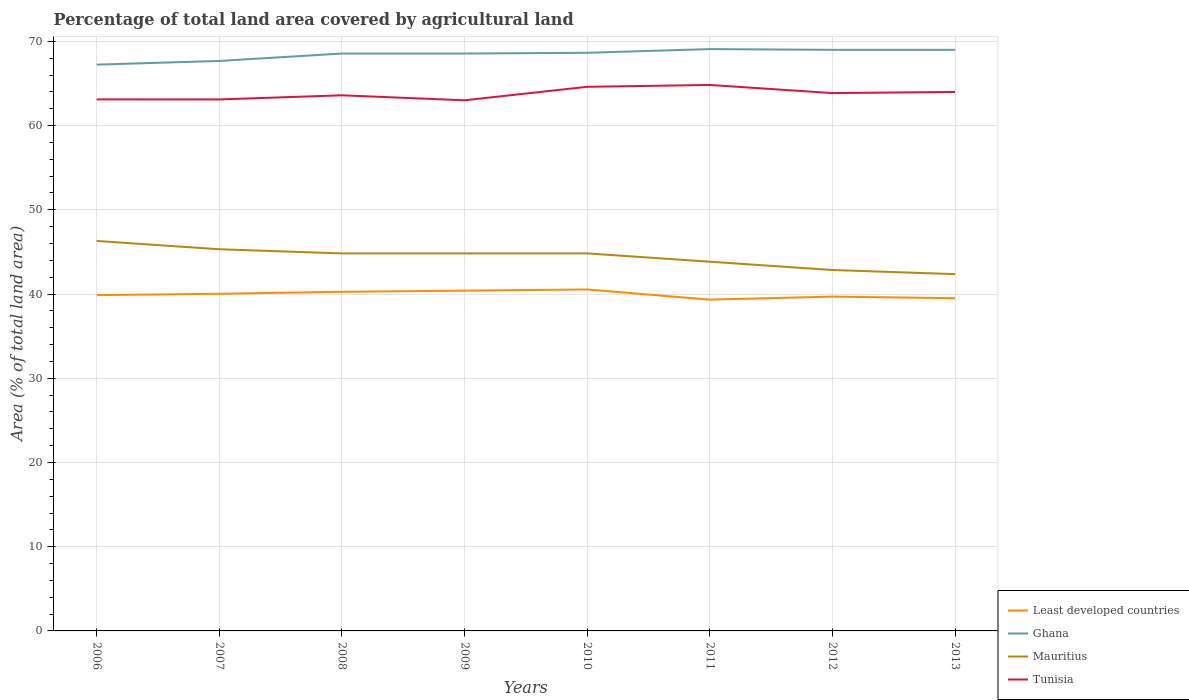Is the number of lines equal to the number of legend labels?
Your answer should be very brief. Yes. Across all years, what is the maximum percentage of agricultural land in Tunisia?
Your response must be concise. 63.01. What is the total percentage of agricultural land in Tunisia in the graph?
Your answer should be very brief. 0.75. What is the difference between the highest and the second highest percentage of agricultural land in Mauritius?
Offer a very short reply. 3.94. Is the percentage of agricultural land in Least developed countries strictly greater than the percentage of agricultural land in Tunisia over the years?
Provide a succinct answer. Yes. How many lines are there?
Provide a short and direct response. 4. What is the difference between two consecutive major ticks on the Y-axis?
Offer a terse response. 10. Does the graph contain grids?
Offer a terse response. Yes. What is the title of the graph?
Offer a very short reply. Percentage of total land area covered by agricultural land. Does "Burkina Faso" appear as one of the legend labels in the graph?
Offer a terse response. No. What is the label or title of the Y-axis?
Your answer should be compact. Area (% of total land area). What is the Area (% of total land area) of Least developed countries in 2006?
Provide a short and direct response. 39.87. What is the Area (% of total land area) of Ghana in 2006?
Provide a succinct answer. 67.24. What is the Area (% of total land area) in Mauritius in 2006?
Ensure brevity in your answer.  46.31. What is the Area (% of total land area) in Tunisia in 2006?
Offer a very short reply. 63.12. What is the Area (% of total land area) in Least developed countries in 2007?
Your answer should be very brief. 40.03. What is the Area (% of total land area) of Ghana in 2007?
Offer a very short reply. 67.68. What is the Area (% of total land area) of Mauritius in 2007?
Your response must be concise. 45.32. What is the Area (% of total land area) in Tunisia in 2007?
Your response must be concise. 63.11. What is the Area (% of total land area) in Least developed countries in 2008?
Give a very brief answer. 40.27. What is the Area (% of total land area) in Ghana in 2008?
Keep it short and to the point. 68.56. What is the Area (% of total land area) in Mauritius in 2008?
Your answer should be compact. 44.83. What is the Area (% of total land area) in Tunisia in 2008?
Your answer should be compact. 63.6. What is the Area (% of total land area) of Least developed countries in 2009?
Keep it short and to the point. 40.41. What is the Area (% of total land area) in Ghana in 2009?
Make the answer very short. 68.56. What is the Area (% of total land area) in Mauritius in 2009?
Keep it short and to the point. 44.83. What is the Area (% of total land area) in Tunisia in 2009?
Ensure brevity in your answer.  63.01. What is the Area (% of total land area) in Least developed countries in 2010?
Keep it short and to the point. 40.54. What is the Area (% of total land area) of Ghana in 2010?
Offer a terse response. 68.65. What is the Area (% of total land area) in Mauritius in 2010?
Keep it short and to the point. 44.83. What is the Area (% of total land area) in Tunisia in 2010?
Your answer should be compact. 64.61. What is the Area (% of total land area) of Least developed countries in 2011?
Your response must be concise. 39.34. What is the Area (% of total land area) in Ghana in 2011?
Give a very brief answer. 69.09. What is the Area (% of total land area) in Mauritius in 2011?
Keep it short and to the point. 43.84. What is the Area (% of total land area) of Tunisia in 2011?
Offer a terse response. 64.83. What is the Area (% of total land area) of Least developed countries in 2012?
Provide a succinct answer. 39.7. What is the Area (% of total land area) in Ghana in 2012?
Ensure brevity in your answer.  69. What is the Area (% of total land area) in Mauritius in 2012?
Offer a terse response. 42.86. What is the Area (% of total land area) in Tunisia in 2012?
Your answer should be compact. 63.86. What is the Area (% of total land area) of Least developed countries in 2013?
Provide a short and direct response. 39.51. What is the Area (% of total land area) of Ghana in 2013?
Provide a succinct answer. 69. What is the Area (% of total land area) of Mauritius in 2013?
Your answer should be compact. 42.36. What is the Area (% of total land area) in Tunisia in 2013?
Ensure brevity in your answer.  64. Across all years, what is the maximum Area (% of total land area) in Least developed countries?
Provide a succinct answer. 40.54. Across all years, what is the maximum Area (% of total land area) of Ghana?
Your answer should be very brief. 69.09. Across all years, what is the maximum Area (% of total land area) of Mauritius?
Provide a short and direct response. 46.31. Across all years, what is the maximum Area (% of total land area) in Tunisia?
Your response must be concise. 64.83. Across all years, what is the minimum Area (% of total land area) of Least developed countries?
Keep it short and to the point. 39.34. Across all years, what is the minimum Area (% of total land area) of Ghana?
Give a very brief answer. 67.24. Across all years, what is the minimum Area (% of total land area) of Mauritius?
Offer a very short reply. 42.36. Across all years, what is the minimum Area (% of total land area) of Tunisia?
Provide a short and direct response. 63.01. What is the total Area (% of total land area) in Least developed countries in the graph?
Give a very brief answer. 319.67. What is the total Area (% of total land area) of Ghana in the graph?
Your answer should be compact. 547.77. What is the total Area (% of total land area) in Mauritius in the graph?
Offer a terse response. 355.17. What is the total Area (% of total land area) in Tunisia in the graph?
Give a very brief answer. 510.14. What is the difference between the Area (% of total land area) in Least developed countries in 2006 and that in 2007?
Your response must be concise. -0.16. What is the difference between the Area (% of total land area) in Ghana in 2006 and that in 2007?
Ensure brevity in your answer.  -0.44. What is the difference between the Area (% of total land area) in Mauritius in 2006 and that in 2007?
Provide a succinct answer. 0.99. What is the difference between the Area (% of total land area) of Tunisia in 2006 and that in 2007?
Offer a very short reply. 0.01. What is the difference between the Area (% of total land area) in Least developed countries in 2006 and that in 2008?
Offer a very short reply. -0.4. What is the difference between the Area (% of total land area) in Ghana in 2006 and that in 2008?
Offer a terse response. -1.32. What is the difference between the Area (% of total land area) in Mauritius in 2006 and that in 2008?
Offer a terse response. 1.48. What is the difference between the Area (% of total land area) in Tunisia in 2006 and that in 2008?
Provide a succinct answer. -0.48. What is the difference between the Area (% of total land area) of Least developed countries in 2006 and that in 2009?
Your response must be concise. -0.54. What is the difference between the Area (% of total land area) of Ghana in 2006 and that in 2009?
Offer a very short reply. -1.32. What is the difference between the Area (% of total land area) of Mauritius in 2006 and that in 2009?
Keep it short and to the point. 1.48. What is the difference between the Area (% of total land area) in Tunisia in 2006 and that in 2009?
Provide a short and direct response. 0.11. What is the difference between the Area (% of total land area) of Least developed countries in 2006 and that in 2010?
Ensure brevity in your answer.  -0.67. What is the difference between the Area (% of total land area) of Ghana in 2006 and that in 2010?
Offer a very short reply. -1.41. What is the difference between the Area (% of total land area) in Mauritius in 2006 and that in 2010?
Offer a terse response. 1.48. What is the difference between the Area (% of total land area) in Tunisia in 2006 and that in 2010?
Offer a terse response. -1.49. What is the difference between the Area (% of total land area) in Least developed countries in 2006 and that in 2011?
Your response must be concise. 0.53. What is the difference between the Area (% of total land area) of Ghana in 2006 and that in 2011?
Provide a succinct answer. -1.85. What is the difference between the Area (% of total land area) in Mauritius in 2006 and that in 2011?
Ensure brevity in your answer.  2.46. What is the difference between the Area (% of total land area) of Tunisia in 2006 and that in 2011?
Give a very brief answer. -1.71. What is the difference between the Area (% of total land area) in Least developed countries in 2006 and that in 2012?
Make the answer very short. 0.17. What is the difference between the Area (% of total land area) in Ghana in 2006 and that in 2012?
Your response must be concise. -1.76. What is the difference between the Area (% of total land area) in Mauritius in 2006 and that in 2012?
Offer a very short reply. 3.45. What is the difference between the Area (% of total land area) in Tunisia in 2006 and that in 2012?
Your response must be concise. -0.75. What is the difference between the Area (% of total land area) of Least developed countries in 2006 and that in 2013?
Your response must be concise. 0.36. What is the difference between the Area (% of total land area) of Ghana in 2006 and that in 2013?
Keep it short and to the point. -1.76. What is the difference between the Area (% of total land area) in Mauritius in 2006 and that in 2013?
Your answer should be compact. 3.94. What is the difference between the Area (% of total land area) in Tunisia in 2006 and that in 2013?
Your response must be concise. -0.88. What is the difference between the Area (% of total land area) in Least developed countries in 2007 and that in 2008?
Ensure brevity in your answer.  -0.23. What is the difference between the Area (% of total land area) of Ghana in 2007 and that in 2008?
Make the answer very short. -0.88. What is the difference between the Area (% of total land area) in Mauritius in 2007 and that in 2008?
Offer a terse response. 0.49. What is the difference between the Area (% of total land area) of Tunisia in 2007 and that in 2008?
Your answer should be compact. -0.49. What is the difference between the Area (% of total land area) in Least developed countries in 2007 and that in 2009?
Your answer should be very brief. -0.37. What is the difference between the Area (% of total land area) in Ghana in 2007 and that in 2009?
Offer a very short reply. -0.88. What is the difference between the Area (% of total land area) of Mauritius in 2007 and that in 2009?
Provide a short and direct response. 0.49. What is the difference between the Area (% of total land area) in Tunisia in 2007 and that in 2009?
Provide a short and direct response. 0.1. What is the difference between the Area (% of total land area) of Least developed countries in 2007 and that in 2010?
Offer a terse response. -0.51. What is the difference between the Area (% of total land area) in Ghana in 2007 and that in 2010?
Keep it short and to the point. -0.97. What is the difference between the Area (% of total land area) in Mauritius in 2007 and that in 2010?
Ensure brevity in your answer.  0.49. What is the difference between the Area (% of total land area) in Tunisia in 2007 and that in 2010?
Your answer should be compact. -1.5. What is the difference between the Area (% of total land area) in Least developed countries in 2007 and that in 2011?
Make the answer very short. 0.69. What is the difference between the Area (% of total land area) in Ghana in 2007 and that in 2011?
Give a very brief answer. -1.41. What is the difference between the Area (% of total land area) in Mauritius in 2007 and that in 2011?
Provide a short and direct response. 1.48. What is the difference between the Area (% of total land area) of Tunisia in 2007 and that in 2011?
Keep it short and to the point. -1.72. What is the difference between the Area (% of total land area) of Least developed countries in 2007 and that in 2012?
Provide a succinct answer. 0.34. What is the difference between the Area (% of total land area) of Ghana in 2007 and that in 2012?
Your answer should be very brief. -1.32. What is the difference between the Area (% of total land area) in Mauritius in 2007 and that in 2012?
Offer a terse response. 2.46. What is the difference between the Area (% of total land area) in Tunisia in 2007 and that in 2012?
Ensure brevity in your answer.  -0.75. What is the difference between the Area (% of total land area) of Least developed countries in 2007 and that in 2013?
Your response must be concise. 0.52. What is the difference between the Area (% of total land area) in Ghana in 2007 and that in 2013?
Your answer should be compact. -1.32. What is the difference between the Area (% of total land area) in Mauritius in 2007 and that in 2013?
Provide a succinct answer. 2.96. What is the difference between the Area (% of total land area) in Tunisia in 2007 and that in 2013?
Keep it short and to the point. -0.89. What is the difference between the Area (% of total land area) in Least developed countries in 2008 and that in 2009?
Ensure brevity in your answer.  -0.14. What is the difference between the Area (% of total land area) in Ghana in 2008 and that in 2009?
Provide a succinct answer. 0. What is the difference between the Area (% of total land area) in Tunisia in 2008 and that in 2009?
Provide a short and direct response. 0.59. What is the difference between the Area (% of total land area) in Least developed countries in 2008 and that in 2010?
Your response must be concise. -0.28. What is the difference between the Area (% of total land area) of Ghana in 2008 and that in 2010?
Provide a succinct answer. -0.09. What is the difference between the Area (% of total land area) in Mauritius in 2008 and that in 2010?
Make the answer very short. 0. What is the difference between the Area (% of total land area) in Tunisia in 2008 and that in 2010?
Your answer should be very brief. -1.01. What is the difference between the Area (% of total land area) of Least developed countries in 2008 and that in 2011?
Your response must be concise. 0.93. What is the difference between the Area (% of total land area) of Ghana in 2008 and that in 2011?
Make the answer very short. -0.53. What is the difference between the Area (% of total land area) of Mauritius in 2008 and that in 2011?
Give a very brief answer. 0.99. What is the difference between the Area (% of total land area) of Tunisia in 2008 and that in 2011?
Give a very brief answer. -1.23. What is the difference between the Area (% of total land area) of Least developed countries in 2008 and that in 2012?
Give a very brief answer. 0.57. What is the difference between the Area (% of total land area) in Ghana in 2008 and that in 2012?
Give a very brief answer. -0.44. What is the difference between the Area (% of total land area) in Mauritius in 2008 and that in 2012?
Provide a short and direct response. 1.97. What is the difference between the Area (% of total land area) in Tunisia in 2008 and that in 2012?
Offer a very short reply. -0.26. What is the difference between the Area (% of total land area) in Least developed countries in 2008 and that in 2013?
Keep it short and to the point. 0.76. What is the difference between the Area (% of total land area) in Ghana in 2008 and that in 2013?
Give a very brief answer. -0.44. What is the difference between the Area (% of total land area) of Mauritius in 2008 and that in 2013?
Provide a succinct answer. 2.46. What is the difference between the Area (% of total land area) in Tunisia in 2008 and that in 2013?
Offer a terse response. -0.4. What is the difference between the Area (% of total land area) in Least developed countries in 2009 and that in 2010?
Provide a succinct answer. -0.14. What is the difference between the Area (% of total land area) of Ghana in 2009 and that in 2010?
Keep it short and to the point. -0.09. What is the difference between the Area (% of total land area) in Mauritius in 2009 and that in 2010?
Make the answer very short. 0. What is the difference between the Area (% of total land area) of Tunisia in 2009 and that in 2010?
Provide a succinct answer. -1.6. What is the difference between the Area (% of total land area) of Least developed countries in 2009 and that in 2011?
Provide a short and direct response. 1.07. What is the difference between the Area (% of total land area) in Ghana in 2009 and that in 2011?
Give a very brief answer. -0.53. What is the difference between the Area (% of total land area) in Mauritius in 2009 and that in 2011?
Ensure brevity in your answer.  0.99. What is the difference between the Area (% of total land area) in Tunisia in 2009 and that in 2011?
Offer a terse response. -1.82. What is the difference between the Area (% of total land area) in Least developed countries in 2009 and that in 2012?
Make the answer very short. 0.71. What is the difference between the Area (% of total land area) in Ghana in 2009 and that in 2012?
Your answer should be very brief. -0.44. What is the difference between the Area (% of total land area) in Mauritius in 2009 and that in 2012?
Keep it short and to the point. 1.97. What is the difference between the Area (% of total land area) in Tunisia in 2009 and that in 2012?
Keep it short and to the point. -0.86. What is the difference between the Area (% of total land area) of Least developed countries in 2009 and that in 2013?
Offer a terse response. 0.9. What is the difference between the Area (% of total land area) of Ghana in 2009 and that in 2013?
Keep it short and to the point. -0.44. What is the difference between the Area (% of total land area) of Mauritius in 2009 and that in 2013?
Your answer should be very brief. 2.46. What is the difference between the Area (% of total land area) of Tunisia in 2009 and that in 2013?
Offer a terse response. -0.99. What is the difference between the Area (% of total land area) in Least developed countries in 2010 and that in 2011?
Offer a terse response. 1.21. What is the difference between the Area (% of total land area) of Ghana in 2010 and that in 2011?
Offer a very short reply. -0.44. What is the difference between the Area (% of total land area) in Mauritius in 2010 and that in 2011?
Provide a succinct answer. 0.99. What is the difference between the Area (% of total land area) in Tunisia in 2010 and that in 2011?
Keep it short and to the point. -0.22. What is the difference between the Area (% of total land area) in Least developed countries in 2010 and that in 2012?
Give a very brief answer. 0.85. What is the difference between the Area (% of total land area) of Ghana in 2010 and that in 2012?
Make the answer very short. -0.35. What is the difference between the Area (% of total land area) in Mauritius in 2010 and that in 2012?
Ensure brevity in your answer.  1.97. What is the difference between the Area (% of total land area) of Tunisia in 2010 and that in 2012?
Keep it short and to the point. 0.75. What is the difference between the Area (% of total land area) of Least developed countries in 2010 and that in 2013?
Your answer should be compact. 1.03. What is the difference between the Area (% of total land area) of Ghana in 2010 and that in 2013?
Provide a short and direct response. -0.35. What is the difference between the Area (% of total land area) in Mauritius in 2010 and that in 2013?
Your answer should be compact. 2.46. What is the difference between the Area (% of total land area) of Tunisia in 2010 and that in 2013?
Make the answer very short. 0.61. What is the difference between the Area (% of total land area) in Least developed countries in 2011 and that in 2012?
Your answer should be very brief. -0.36. What is the difference between the Area (% of total land area) of Ghana in 2011 and that in 2012?
Your response must be concise. 0.09. What is the difference between the Area (% of total land area) of Mauritius in 2011 and that in 2012?
Your response must be concise. 0.99. What is the difference between the Area (% of total land area) in Tunisia in 2011 and that in 2012?
Your answer should be compact. 0.97. What is the difference between the Area (% of total land area) of Least developed countries in 2011 and that in 2013?
Give a very brief answer. -0.17. What is the difference between the Area (% of total land area) in Ghana in 2011 and that in 2013?
Provide a short and direct response. 0.09. What is the difference between the Area (% of total land area) in Mauritius in 2011 and that in 2013?
Your response must be concise. 1.48. What is the difference between the Area (% of total land area) of Tunisia in 2011 and that in 2013?
Provide a succinct answer. 0.83. What is the difference between the Area (% of total land area) in Least developed countries in 2012 and that in 2013?
Provide a short and direct response. 0.19. What is the difference between the Area (% of total land area) in Ghana in 2012 and that in 2013?
Keep it short and to the point. 0. What is the difference between the Area (% of total land area) in Mauritius in 2012 and that in 2013?
Give a very brief answer. 0.49. What is the difference between the Area (% of total land area) in Tunisia in 2012 and that in 2013?
Give a very brief answer. -0.14. What is the difference between the Area (% of total land area) of Least developed countries in 2006 and the Area (% of total land area) of Ghana in 2007?
Your response must be concise. -27.81. What is the difference between the Area (% of total land area) of Least developed countries in 2006 and the Area (% of total land area) of Mauritius in 2007?
Your answer should be compact. -5.45. What is the difference between the Area (% of total land area) of Least developed countries in 2006 and the Area (% of total land area) of Tunisia in 2007?
Give a very brief answer. -23.24. What is the difference between the Area (% of total land area) in Ghana in 2006 and the Area (% of total land area) in Mauritius in 2007?
Ensure brevity in your answer.  21.92. What is the difference between the Area (% of total land area) of Ghana in 2006 and the Area (% of total land area) of Tunisia in 2007?
Your answer should be very brief. 4.13. What is the difference between the Area (% of total land area) of Mauritius in 2006 and the Area (% of total land area) of Tunisia in 2007?
Your response must be concise. -16.81. What is the difference between the Area (% of total land area) of Least developed countries in 2006 and the Area (% of total land area) of Ghana in 2008?
Keep it short and to the point. -28.69. What is the difference between the Area (% of total land area) in Least developed countries in 2006 and the Area (% of total land area) in Mauritius in 2008?
Offer a very short reply. -4.96. What is the difference between the Area (% of total land area) in Least developed countries in 2006 and the Area (% of total land area) in Tunisia in 2008?
Ensure brevity in your answer.  -23.73. What is the difference between the Area (% of total land area) of Ghana in 2006 and the Area (% of total land area) of Mauritius in 2008?
Your answer should be compact. 22.41. What is the difference between the Area (% of total land area) in Ghana in 2006 and the Area (% of total land area) in Tunisia in 2008?
Ensure brevity in your answer.  3.64. What is the difference between the Area (% of total land area) of Mauritius in 2006 and the Area (% of total land area) of Tunisia in 2008?
Your answer should be compact. -17.3. What is the difference between the Area (% of total land area) of Least developed countries in 2006 and the Area (% of total land area) of Ghana in 2009?
Offer a terse response. -28.69. What is the difference between the Area (% of total land area) in Least developed countries in 2006 and the Area (% of total land area) in Mauritius in 2009?
Ensure brevity in your answer.  -4.96. What is the difference between the Area (% of total land area) in Least developed countries in 2006 and the Area (% of total land area) in Tunisia in 2009?
Your answer should be very brief. -23.14. What is the difference between the Area (% of total land area) in Ghana in 2006 and the Area (% of total land area) in Mauritius in 2009?
Offer a very short reply. 22.41. What is the difference between the Area (% of total land area) of Ghana in 2006 and the Area (% of total land area) of Tunisia in 2009?
Ensure brevity in your answer.  4.23. What is the difference between the Area (% of total land area) of Mauritius in 2006 and the Area (% of total land area) of Tunisia in 2009?
Offer a very short reply. -16.7. What is the difference between the Area (% of total land area) of Least developed countries in 2006 and the Area (% of total land area) of Ghana in 2010?
Keep it short and to the point. -28.78. What is the difference between the Area (% of total land area) in Least developed countries in 2006 and the Area (% of total land area) in Mauritius in 2010?
Your answer should be very brief. -4.96. What is the difference between the Area (% of total land area) of Least developed countries in 2006 and the Area (% of total land area) of Tunisia in 2010?
Provide a succinct answer. -24.74. What is the difference between the Area (% of total land area) of Ghana in 2006 and the Area (% of total land area) of Mauritius in 2010?
Offer a terse response. 22.41. What is the difference between the Area (% of total land area) in Ghana in 2006 and the Area (% of total land area) in Tunisia in 2010?
Give a very brief answer. 2.63. What is the difference between the Area (% of total land area) in Mauritius in 2006 and the Area (% of total land area) in Tunisia in 2010?
Ensure brevity in your answer.  -18.31. What is the difference between the Area (% of total land area) in Least developed countries in 2006 and the Area (% of total land area) in Ghana in 2011?
Give a very brief answer. -29.22. What is the difference between the Area (% of total land area) in Least developed countries in 2006 and the Area (% of total land area) in Mauritius in 2011?
Provide a succinct answer. -3.97. What is the difference between the Area (% of total land area) in Least developed countries in 2006 and the Area (% of total land area) in Tunisia in 2011?
Provide a succinct answer. -24.96. What is the difference between the Area (% of total land area) of Ghana in 2006 and the Area (% of total land area) of Mauritius in 2011?
Your response must be concise. 23.4. What is the difference between the Area (% of total land area) in Ghana in 2006 and the Area (% of total land area) in Tunisia in 2011?
Your answer should be compact. 2.41. What is the difference between the Area (% of total land area) of Mauritius in 2006 and the Area (% of total land area) of Tunisia in 2011?
Keep it short and to the point. -18.52. What is the difference between the Area (% of total land area) of Least developed countries in 2006 and the Area (% of total land area) of Ghana in 2012?
Offer a very short reply. -29.13. What is the difference between the Area (% of total land area) of Least developed countries in 2006 and the Area (% of total land area) of Mauritius in 2012?
Make the answer very short. -2.99. What is the difference between the Area (% of total land area) of Least developed countries in 2006 and the Area (% of total land area) of Tunisia in 2012?
Your response must be concise. -23.99. What is the difference between the Area (% of total land area) of Ghana in 2006 and the Area (% of total land area) of Mauritius in 2012?
Your answer should be compact. 24.38. What is the difference between the Area (% of total land area) in Ghana in 2006 and the Area (% of total land area) in Tunisia in 2012?
Keep it short and to the point. 3.38. What is the difference between the Area (% of total land area) in Mauritius in 2006 and the Area (% of total land area) in Tunisia in 2012?
Make the answer very short. -17.56. What is the difference between the Area (% of total land area) of Least developed countries in 2006 and the Area (% of total land area) of Ghana in 2013?
Provide a succinct answer. -29.13. What is the difference between the Area (% of total land area) in Least developed countries in 2006 and the Area (% of total land area) in Mauritius in 2013?
Provide a short and direct response. -2.49. What is the difference between the Area (% of total land area) of Least developed countries in 2006 and the Area (% of total land area) of Tunisia in 2013?
Provide a succinct answer. -24.13. What is the difference between the Area (% of total land area) of Ghana in 2006 and the Area (% of total land area) of Mauritius in 2013?
Your response must be concise. 24.88. What is the difference between the Area (% of total land area) in Ghana in 2006 and the Area (% of total land area) in Tunisia in 2013?
Provide a short and direct response. 3.24. What is the difference between the Area (% of total land area) of Mauritius in 2006 and the Area (% of total land area) of Tunisia in 2013?
Ensure brevity in your answer.  -17.69. What is the difference between the Area (% of total land area) of Least developed countries in 2007 and the Area (% of total land area) of Ghana in 2008?
Make the answer very short. -28.53. What is the difference between the Area (% of total land area) of Least developed countries in 2007 and the Area (% of total land area) of Mauritius in 2008?
Your response must be concise. -4.79. What is the difference between the Area (% of total land area) of Least developed countries in 2007 and the Area (% of total land area) of Tunisia in 2008?
Provide a short and direct response. -23.57. What is the difference between the Area (% of total land area) of Ghana in 2007 and the Area (% of total land area) of Mauritius in 2008?
Ensure brevity in your answer.  22.85. What is the difference between the Area (% of total land area) in Ghana in 2007 and the Area (% of total land area) in Tunisia in 2008?
Provide a short and direct response. 4.08. What is the difference between the Area (% of total land area) in Mauritius in 2007 and the Area (% of total land area) in Tunisia in 2008?
Ensure brevity in your answer.  -18.28. What is the difference between the Area (% of total land area) in Least developed countries in 2007 and the Area (% of total land area) in Ghana in 2009?
Provide a succinct answer. -28.53. What is the difference between the Area (% of total land area) in Least developed countries in 2007 and the Area (% of total land area) in Mauritius in 2009?
Give a very brief answer. -4.79. What is the difference between the Area (% of total land area) in Least developed countries in 2007 and the Area (% of total land area) in Tunisia in 2009?
Your answer should be very brief. -22.97. What is the difference between the Area (% of total land area) of Ghana in 2007 and the Area (% of total land area) of Mauritius in 2009?
Your answer should be very brief. 22.85. What is the difference between the Area (% of total land area) of Ghana in 2007 and the Area (% of total land area) of Tunisia in 2009?
Give a very brief answer. 4.67. What is the difference between the Area (% of total land area) of Mauritius in 2007 and the Area (% of total land area) of Tunisia in 2009?
Make the answer very short. -17.69. What is the difference between the Area (% of total land area) of Least developed countries in 2007 and the Area (% of total land area) of Ghana in 2010?
Provide a succinct answer. -28.61. What is the difference between the Area (% of total land area) of Least developed countries in 2007 and the Area (% of total land area) of Mauritius in 2010?
Make the answer very short. -4.79. What is the difference between the Area (% of total land area) of Least developed countries in 2007 and the Area (% of total land area) of Tunisia in 2010?
Offer a terse response. -24.58. What is the difference between the Area (% of total land area) of Ghana in 2007 and the Area (% of total land area) of Mauritius in 2010?
Ensure brevity in your answer.  22.85. What is the difference between the Area (% of total land area) in Ghana in 2007 and the Area (% of total land area) in Tunisia in 2010?
Provide a short and direct response. 3.07. What is the difference between the Area (% of total land area) in Mauritius in 2007 and the Area (% of total land area) in Tunisia in 2010?
Your response must be concise. -19.29. What is the difference between the Area (% of total land area) of Least developed countries in 2007 and the Area (% of total land area) of Ghana in 2011?
Offer a very short reply. -29.05. What is the difference between the Area (% of total land area) in Least developed countries in 2007 and the Area (% of total land area) in Mauritius in 2011?
Offer a very short reply. -3.81. What is the difference between the Area (% of total land area) of Least developed countries in 2007 and the Area (% of total land area) of Tunisia in 2011?
Offer a terse response. -24.8. What is the difference between the Area (% of total land area) of Ghana in 2007 and the Area (% of total land area) of Mauritius in 2011?
Provide a short and direct response. 23.84. What is the difference between the Area (% of total land area) in Ghana in 2007 and the Area (% of total land area) in Tunisia in 2011?
Give a very brief answer. 2.85. What is the difference between the Area (% of total land area) in Mauritius in 2007 and the Area (% of total land area) in Tunisia in 2011?
Keep it short and to the point. -19.51. What is the difference between the Area (% of total land area) in Least developed countries in 2007 and the Area (% of total land area) in Ghana in 2012?
Your answer should be compact. -28.97. What is the difference between the Area (% of total land area) of Least developed countries in 2007 and the Area (% of total land area) of Mauritius in 2012?
Your answer should be compact. -2.82. What is the difference between the Area (% of total land area) in Least developed countries in 2007 and the Area (% of total land area) in Tunisia in 2012?
Your response must be concise. -23.83. What is the difference between the Area (% of total land area) in Ghana in 2007 and the Area (% of total land area) in Mauritius in 2012?
Ensure brevity in your answer.  24.82. What is the difference between the Area (% of total land area) of Ghana in 2007 and the Area (% of total land area) of Tunisia in 2012?
Your answer should be very brief. 3.82. What is the difference between the Area (% of total land area) in Mauritius in 2007 and the Area (% of total land area) in Tunisia in 2012?
Provide a short and direct response. -18.54. What is the difference between the Area (% of total land area) of Least developed countries in 2007 and the Area (% of total land area) of Ghana in 2013?
Your answer should be compact. -28.97. What is the difference between the Area (% of total land area) in Least developed countries in 2007 and the Area (% of total land area) in Mauritius in 2013?
Your answer should be very brief. -2.33. What is the difference between the Area (% of total land area) of Least developed countries in 2007 and the Area (% of total land area) of Tunisia in 2013?
Your answer should be compact. -23.97. What is the difference between the Area (% of total land area) of Ghana in 2007 and the Area (% of total land area) of Mauritius in 2013?
Your answer should be very brief. 25.32. What is the difference between the Area (% of total land area) of Ghana in 2007 and the Area (% of total land area) of Tunisia in 2013?
Your response must be concise. 3.68. What is the difference between the Area (% of total land area) in Mauritius in 2007 and the Area (% of total land area) in Tunisia in 2013?
Make the answer very short. -18.68. What is the difference between the Area (% of total land area) of Least developed countries in 2008 and the Area (% of total land area) of Ghana in 2009?
Your answer should be compact. -28.29. What is the difference between the Area (% of total land area) of Least developed countries in 2008 and the Area (% of total land area) of Mauritius in 2009?
Your answer should be very brief. -4.56. What is the difference between the Area (% of total land area) of Least developed countries in 2008 and the Area (% of total land area) of Tunisia in 2009?
Your answer should be very brief. -22.74. What is the difference between the Area (% of total land area) of Ghana in 2008 and the Area (% of total land area) of Mauritius in 2009?
Offer a terse response. 23.73. What is the difference between the Area (% of total land area) in Ghana in 2008 and the Area (% of total land area) in Tunisia in 2009?
Make the answer very short. 5.55. What is the difference between the Area (% of total land area) in Mauritius in 2008 and the Area (% of total land area) in Tunisia in 2009?
Keep it short and to the point. -18.18. What is the difference between the Area (% of total land area) in Least developed countries in 2008 and the Area (% of total land area) in Ghana in 2010?
Your answer should be compact. -28.38. What is the difference between the Area (% of total land area) of Least developed countries in 2008 and the Area (% of total land area) of Mauritius in 2010?
Your answer should be very brief. -4.56. What is the difference between the Area (% of total land area) of Least developed countries in 2008 and the Area (% of total land area) of Tunisia in 2010?
Make the answer very short. -24.34. What is the difference between the Area (% of total land area) in Ghana in 2008 and the Area (% of total land area) in Mauritius in 2010?
Provide a short and direct response. 23.73. What is the difference between the Area (% of total land area) of Ghana in 2008 and the Area (% of total land area) of Tunisia in 2010?
Ensure brevity in your answer.  3.95. What is the difference between the Area (% of total land area) of Mauritius in 2008 and the Area (% of total land area) of Tunisia in 2010?
Provide a short and direct response. -19.78. What is the difference between the Area (% of total land area) of Least developed countries in 2008 and the Area (% of total land area) of Ghana in 2011?
Ensure brevity in your answer.  -28.82. What is the difference between the Area (% of total land area) of Least developed countries in 2008 and the Area (% of total land area) of Mauritius in 2011?
Your answer should be very brief. -3.58. What is the difference between the Area (% of total land area) of Least developed countries in 2008 and the Area (% of total land area) of Tunisia in 2011?
Offer a terse response. -24.56. What is the difference between the Area (% of total land area) of Ghana in 2008 and the Area (% of total land area) of Mauritius in 2011?
Give a very brief answer. 24.72. What is the difference between the Area (% of total land area) in Ghana in 2008 and the Area (% of total land area) in Tunisia in 2011?
Ensure brevity in your answer.  3.73. What is the difference between the Area (% of total land area) in Mauritius in 2008 and the Area (% of total land area) in Tunisia in 2011?
Ensure brevity in your answer.  -20. What is the difference between the Area (% of total land area) in Least developed countries in 2008 and the Area (% of total land area) in Ghana in 2012?
Keep it short and to the point. -28.73. What is the difference between the Area (% of total land area) of Least developed countries in 2008 and the Area (% of total land area) of Mauritius in 2012?
Offer a terse response. -2.59. What is the difference between the Area (% of total land area) in Least developed countries in 2008 and the Area (% of total land area) in Tunisia in 2012?
Provide a short and direct response. -23.6. What is the difference between the Area (% of total land area) in Ghana in 2008 and the Area (% of total land area) in Mauritius in 2012?
Your answer should be very brief. 25.7. What is the difference between the Area (% of total land area) in Ghana in 2008 and the Area (% of total land area) in Tunisia in 2012?
Keep it short and to the point. 4.69. What is the difference between the Area (% of total land area) in Mauritius in 2008 and the Area (% of total land area) in Tunisia in 2012?
Give a very brief answer. -19.04. What is the difference between the Area (% of total land area) of Least developed countries in 2008 and the Area (% of total land area) of Ghana in 2013?
Your answer should be very brief. -28.73. What is the difference between the Area (% of total land area) of Least developed countries in 2008 and the Area (% of total land area) of Mauritius in 2013?
Your response must be concise. -2.1. What is the difference between the Area (% of total land area) in Least developed countries in 2008 and the Area (% of total land area) in Tunisia in 2013?
Offer a terse response. -23.73. What is the difference between the Area (% of total land area) in Ghana in 2008 and the Area (% of total land area) in Mauritius in 2013?
Provide a short and direct response. 26.19. What is the difference between the Area (% of total land area) in Ghana in 2008 and the Area (% of total land area) in Tunisia in 2013?
Your response must be concise. 4.56. What is the difference between the Area (% of total land area) of Mauritius in 2008 and the Area (% of total land area) of Tunisia in 2013?
Provide a succinct answer. -19.17. What is the difference between the Area (% of total land area) of Least developed countries in 2009 and the Area (% of total land area) of Ghana in 2010?
Give a very brief answer. -28.24. What is the difference between the Area (% of total land area) in Least developed countries in 2009 and the Area (% of total land area) in Mauritius in 2010?
Give a very brief answer. -4.42. What is the difference between the Area (% of total land area) of Least developed countries in 2009 and the Area (% of total land area) of Tunisia in 2010?
Give a very brief answer. -24.2. What is the difference between the Area (% of total land area) in Ghana in 2009 and the Area (% of total land area) in Mauritius in 2010?
Your answer should be compact. 23.73. What is the difference between the Area (% of total land area) in Ghana in 2009 and the Area (% of total land area) in Tunisia in 2010?
Make the answer very short. 3.95. What is the difference between the Area (% of total land area) in Mauritius in 2009 and the Area (% of total land area) in Tunisia in 2010?
Keep it short and to the point. -19.78. What is the difference between the Area (% of total land area) of Least developed countries in 2009 and the Area (% of total land area) of Ghana in 2011?
Provide a short and direct response. -28.68. What is the difference between the Area (% of total land area) in Least developed countries in 2009 and the Area (% of total land area) in Mauritius in 2011?
Provide a succinct answer. -3.43. What is the difference between the Area (% of total land area) in Least developed countries in 2009 and the Area (% of total land area) in Tunisia in 2011?
Provide a succinct answer. -24.42. What is the difference between the Area (% of total land area) of Ghana in 2009 and the Area (% of total land area) of Mauritius in 2011?
Your response must be concise. 24.72. What is the difference between the Area (% of total land area) in Ghana in 2009 and the Area (% of total land area) in Tunisia in 2011?
Your answer should be compact. 3.73. What is the difference between the Area (% of total land area) in Mauritius in 2009 and the Area (% of total land area) in Tunisia in 2011?
Ensure brevity in your answer.  -20. What is the difference between the Area (% of total land area) in Least developed countries in 2009 and the Area (% of total land area) in Ghana in 2012?
Ensure brevity in your answer.  -28.59. What is the difference between the Area (% of total land area) of Least developed countries in 2009 and the Area (% of total land area) of Mauritius in 2012?
Keep it short and to the point. -2.45. What is the difference between the Area (% of total land area) of Least developed countries in 2009 and the Area (% of total land area) of Tunisia in 2012?
Make the answer very short. -23.46. What is the difference between the Area (% of total land area) in Ghana in 2009 and the Area (% of total land area) in Mauritius in 2012?
Offer a terse response. 25.7. What is the difference between the Area (% of total land area) of Ghana in 2009 and the Area (% of total land area) of Tunisia in 2012?
Give a very brief answer. 4.69. What is the difference between the Area (% of total land area) of Mauritius in 2009 and the Area (% of total land area) of Tunisia in 2012?
Your response must be concise. -19.04. What is the difference between the Area (% of total land area) of Least developed countries in 2009 and the Area (% of total land area) of Ghana in 2013?
Your answer should be very brief. -28.59. What is the difference between the Area (% of total land area) of Least developed countries in 2009 and the Area (% of total land area) of Mauritius in 2013?
Your answer should be very brief. -1.96. What is the difference between the Area (% of total land area) of Least developed countries in 2009 and the Area (% of total land area) of Tunisia in 2013?
Your answer should be very brief. -23.59. What is the difference between the Area (% of total land area) of Ghana in 2009 and the Area (% of total land area) of Mauritius in 2013?
Your answer should be very brief. 26.19. What is the difference between the Area (% of total land area) in Ghana in 2009 and the Area (% of total land area) in Tunisia in 2013?
Give a very brief answer. 4.56. What is the difference between the Area (% of total land area) in Mauritius in 2009 and the Area (% of total land area) in Tunisia in 2013?
Offer a terse response. -19.17. What is the difference between the Area (% of total land area) in Least developed countries in 2010 and the Area (% of total land area) in Ghana in 2011?
Provide a short and direct response. -28.54. What is the difference between the Area (% of total land area) of Least developed countries in 2010 and the Area (% of total land area) of Mauritius in 2011?
Keep it short and to the point. -3.3. What is the difference between the Area (% of total land area) in Least developed countries in 2010 and the Area (% of total land area) in Tunisia in 2011?
Provide a succinct answer. -24.29. What is the difference between the Area (% of total land area) of Ghana in 2010 and the Area (% of total land area) of Mauritius in 2011?
Your answer should be very brief. 24.8. What is the difference between the Area (% of total land area) of Ghana in 2010 and the Area (% of total land area) of Tunisia in 2011?
Provide a short and direct response. 3.82. What is the difference between the Area (% of total land area) in Mauritius in 2010 and the Area (% of total land area) in Tunisia in 2011?
Your response must be concise. -20. What is the difference between the Area (% of total land area) in Least developed countries in 2010 and the Area (% of total land area) in Ghana in 2012?
Ensure brevity in your answer.  -28.45. What is the difference between the Area (% of total land area) of Least developed countries in 2010 and the Area (% of total land area) of Mauritius in 2012?
Your answer should be very brief. -2.31. What is the difference between the Area (% of total land area) of Least developed countries in 2010 and the Area (% of total land area) of Tunisia in 2012?
Your answer should be very brief. -23.32. What is the difference between the Area (% of total land area) of Ghana in 2010 and the Area (% of total land area) of Mauritius in 2012?
Ensure brevity in your answer.  25.79. What is the difference between the Area (% of total land area) of Ghana in 2010 and the Area (% of total land area) of Tunisia in 2012?
Offer a very short reply. 4.78. What is the difference between the Area (% of total land area) in Mauritius in 2010 and the Area (% of total land area) in Tunisia in 2012?
Provide a succinct answer. -19.04. What is the difference between the Area (% of total land area) in Least developed countries in 2010 and the Area (% of total land area) in Ghana in 2013?
Make the answer very short. -28.45. What is the difference between the Area (% of total land area) in Least developed countries in 2010 and the Area (% of total land area) in Mauritius in 2013?
Provide a succinct answer. -1.82. What is the difference between the Area (% of total land area) of Least developed countries in 2010 and the Area (% of total land area) of Tunisia in 2013?
Ensure brevity in your answer.  -23.45. What is the difference between the Area (% of total land area) in Ghana in 2010 and the Area (% of total land area) in Mauritius in 2013?
Provide a short and direct response. 26.28. What is the difference between the Area (% of total land area) in Ghana in 2010 and the Area (% of total land area) in Tunisia in 2013?
Make the answer very short. 4.65. What is the difference between the Area (% of total land area) in Mauritius in 2010 and the Area (% of total land area) in Tunisia in 2013?
Make the answer very short. -19.17. What is the difference between the Area (% of total land area) in Least developed countries in 2011 and the Area (% of total land area) in Ghana in 2012?
Offer a terse response. -29.66. What is the difference between the Area (% of total land area) in Least developed countries in 2011 and the Area (% of total land area) in Mauritius in 2012?
Your answer should be very brief. -3.52. What is the difference between the Area (% of total land area) of Least developed countries in 2011 and the Area (% of total land area) of Tunisia in 2012?
Your answer should be compact. -24.53. What is the difference between the Area (% of total land area) of Ghana in 2011 and the Area (% of total land area) of Mauritius in 2012?
Give a very brief answer. 26.23. What is the difference between the Area (% of total land area) of Ghana in 2011 and the Area (% of total land area) of Tunisia in 2012?
Your answer should be very brief. 5.22. What is the difference between the Area (% of total land area) of Mauritius in 2011 and the Area (% of total land area) of Tunisia in 2012?
Ensure brevity in your answer.  -20.02. What is the difference between the Area (% of total land area) of Least developed countries in 2011 and the Area (% of total land area) of Ghana in 2013?
Your answer should be very brief. -29.66. What is the difference between the Area (% of total land area) in Least developed countries in 2011 and the Area (% of total land area) in Mauritius in 2013?
Keep it short and to the point. -3.03. What is the difference between the Area (% of total land area) of Least developed countries in 2011 and the Area (% of total land area) of Tunisia in 2013?
Make the answer very short. -24.66. What is the difference between the Area (% of total land area) of Ghana in 2011 and the Area (% of total land area) of Mauritius in 2013?
Provide a succinct answer. 26.72. What is the difference between the Area (% of total land area) of Ghana in 2011 and the Area (% of total land area) of Tunisia in 2013?
Keep it short and to the point. 5.09. What is the difference between the Area (% of total land area) of Mauritius in 2011 and the Area (% of total land area) of Tunisia in 2013?
Keep it short and to the point. -20.16. What is the difference between the Area (% of total land area) of Least developed countries in 2012 and the Area (% of total land area) of Ghana in 2013?
Ensure brevity in your answer.  -29.3. What is the difference between the Area (% of total land area) in Least developed countries in 2012 and the Area (% of total land area) in Mauritius in 2013?
Make the answer very short. -2.67. What is the difference between the Area (% of total land area) in Least developed countries in 2012 and the Area (% of total land area) in Tunisia in 2013?
Keep it short and to the point. -24.3. What is the difference between the Area (% of total land area) in Ghana in 2012 and the Area (% of total land area) in Mauritius in 2013?
Your answer should be very brief. 26.63. What is the difference between the Area (% of total land area) in Ghana in 2012 and the Area (% of total land area) in Tunisia in 2013?
Provide a short and direct response. 5. What is the difference between the Area (% of total land area) in Mauritius in 2012 and the Area (% of total land area) in Tunisia in 2013?
Make the answer very short. -21.14. What is the average Area (% of total land area) in Least developed countries per year?
Offer a very short reply. 39.96. What is the average Area (% of total land area) of Ghana per year?
Give a very brief answer. 68.47. What is the average Area (% of total land area) of Mauritius per year?
Your answer should be very brief. 44.4. What is the average Area (% of total land area) of Tunisia per year?
Provide a succinct answer. 63.77. In the year 2006, what is the difference between the Area (% of total land area) in Least developed countries and Area (% of total land area) in Ghana?
Make the answer very short. -27.37. In the year 2006, what is the difference between the Area (% of total land area) of Least developed countries and Area (% of total land area) of Mauritius?
Give a very brief answer. -6.43. In the year 2006, what is the difference between the Area (% of total land area) of Least developed countries and Area (% of total land area) of Tunisia?
Provide a succinct answer. -23.25. In the year 2006, what is the difference between the Area (% of total land area) in Ghana and Area (% of total land area) in Mauritius?
Offer a very short reply. 20.94. In the year 2006, what is the difference between the Area (% of total land area) of Ghana and Area (% of total land area) of Tunisia?
Provide a short and direct response. 4.12. In the year 2006, what is the difference between the Area (% of total land area) in Mauritius and Area (% of total land area) in Tunisia?
Provide a succinct answer. -16.81. In the year 2007, what is the difference between the Area (% of total land area) of Least developed countries and Area (% of total land area) of Ghana?
Provide a succinct answer. -27.65. In the year 2007, what is the difference between the Area (% of total land area) in Least developed countries and Area (% of total land area) in Mauritius?
Offer a terse response. -5.29. In the year 2007, what is the difference between the Area (% of total land area) of Least developed countries and Area (% of total land area) of Tunisia?
Offer a very short reply. -23.08. In the year 2007, what is the difference between the Area (% of total land area) of Ghana and Area (% of total land area) of Mauritius?
Ensure brevity in your answer.  22.36. In the year 2007, what is the difference between the Area (% of total land area) in Ghana and Area (% of total land area) in Tunisia?
Your response must be concise. 4.57. In the year 2007, what is the difference between the Area (% of total land area) of Mauritius and Area (% of total land area) of Tunisia?
Your response must be concise. -17.79. In the year 2008, what is the difference between the Area (% of total land area) in Least developed countries and Area (% of total land area) in Ghana?
Provide a short and direct response. -28.29. In the year 2008, what is the difference between the Area (% of total land area) in Least developed countries and Area (% of total land area) in Mauritius?
Give a very brief answer. -4.56. In the year 2008, what is the difference between the Area (% of total land area) of Least developed countries and Area (% of total land area) of Tunisia?
Provide a short and direct response. -23.33. In the year 2008, what is the difference between the Area (% of total land area) of Ghana and Area (% of total land area) of Mauritius?
Your answer should be very brief. 23.73. In the year 2008, what is the difference between the Area (% of total land area) of Ghana and Area (% of total land area) of Tunisia?
Your answer should be very brief. 4.96. In the year 2008, what is the difference between the Area (% of total land area) of Mauritius and Area (% of total land area) of Tunisia?
Your answer should be very brief. -18.77. In the year 2009, what is the difference between the Area (% of total land area) in Least developed countries and Area (% of total land area) in Ghana?
Make the answer very short. -28.15. In the year 2009, what is the difference between the Area (% of total land area) in Least developed countries and Area (% of total land area) in Mauritius?
Provide a short and direct response. -4.42. In the year 2009, what is the difference between the Area (% of total land area) in Least developed countries and Area (% of total land area) in Tunisia?
Your answer should be compact. -22.6. In the year 2009, what is the difference between the Area (% of total land area) of Ghana and Area (% of total land area) of Mauritius?
Your answer should be very brief. 23.73. In the year 2009, what is the difference between the Area (% of total land area) in Ghana and Area (% of total land area) in Tunisia?
Provide a short and direct response. 5.55. In the year 2009, what is the difference between the Area (% of total land area) of Mauritius and Area (% of total land area) of Tunisia?
Your response must be concise. -18.18. In the year 2010, what is the difference between the Area (% of total land area) in Least developed countries and Area (% of total land area) in Ghana?
Offer a very short reply. -28.1. In the year 2010, what is the difference between the Area (% of total land area) of Least developed countries and Area (% of total land area) of Mauritius?
Your answer should be compact. -4.28. In the year 2010, what is the difference between the Area (% of total land area) in Least developed countries and Area (% of total land area) in Tunisia?
Ensure brevity in your answer.  -24.07. In the year 2010, what is the difference between the Area (% of total land area) of Ghana and Area (% of total land area) of Mauritius?
Keep it short and to the point. 23.82. In the year 2010, what is the difference between the Area (% of total land area) in Ghana and Area (% of total land area) in Tunisia?
Give a very brief answer. 4.04. In the year 2010, what is the difference between the Area (% of total land area) in Mauritius and Area (% of total land area) in Tunisia?
Offer a very short reply. -19.78. In the year 2011, what is the difference between the Area (% of total land area) of Least developed countries and Area (% of total land area) of Ghana?
Give a very brief answer. -29.75. In the year 2011, what is the difference between the Area (% of total land area) in Least developed countries and Area (% of total land area) in Mauritius?
Your answer should be very brief. -4.5. In the year 2011, what is the difference between the Area (% of total land area) of Least developed countries and Area (% of total land area) of Tunisia?
Keep it short and to the point. -25.49. In the year 2011, what is the difference between the Area (% of total land area) of Ghana and Area (% of total land area) of Mauritius?
Provide a succinct answer. 25.24. In the year 2011, what is the difference between the Area (% of total land area) of Ghana and Area (% of total land area) of Tunisia?
Your response must be concise. 4.26. In the year 2011, what is the difference between the Area (% of total land area) of Mauritius and Area (% of total land area) of Tunisia?
Keep it short and to the point. -20.99. In the year 2012, what is the difference between the Area (% of total land area) of Least developed countries and Area (% of total land area) of Ghana?
Provide a succinct answer. -29.3. In the year 2012, what is the difference between the Area (% of total land area) of Least developed countries and Area (% of total land area) of Mauritius?
Your answer should be compact. -3.16. In the year 2012, what is the difference between the Area (% of total land area) in Least developed countries and Area (% of total land area) in Tunisia?
Your response must be concise. -24.17. In the year 2012, what is the difference between the Area (% of total land area) in Ghana and Area (% of total land area) in Mauritius?
Your response must be concise. 26.14. In the year 2012, what is the difference between the Area (% of total land area) of Ghana and Area (% of total land area) of Tunisia?
Keep it short and to the point. 5.13. In the year 2012, what is the difference between the Area (% of total land area) of Mauritius and Area (% of total land area) of Tunisia?
Your answer should be very brief. -21.01. In the year 2013, what is the difference between the Area (% of total land area) of Least developed countries and Area (% of total land area) of Ghana?
Keep it short and to the point. -29.49. In the year 2013, what is the difference between the Area (% of total land area) in Least developed countries and Area (% of total land area) in Mauritius?
Your answer should be compact. -2.85. In the year 2013, what is the difference between the Area (% of total land area) in Least developed countries and Area (% of total land area) in Tunisia?
Give a very brief answer. -24.49. In the year 2013, what is the difference between the Area (% of total land area) of Ghana and Area (% of total land area) of Mauritius?
Keep it short and to the point. 26.63. In the year 2013, what is the difference between the Area (% of total land area) of Ghana and Area (% of total land area) of Tunisia?
Keep it short and to the point. 5. In the year 2013, what is the difference between the Area (% of total land area) in Mauritius and Area (% of total land area) in Tunisia?
Give a very brief answer. -21.64. What is the ratio of the Area (% of total land area) of Ghana in 2006 to that in 2007?
Your answer should be compact. 0.99. What is the ratio of the Area (% of total land area) in Mauritius in 2006 to that in 2007?
Ensure brevity in your answer.  1.02. What is the ratio of the Area (% of total land area) in Tunisia in 2006 to that in 2007?
Provide a succinct answer. 1. What is the ratio of the Area (% of total land area) of Least developed countries in 2006 to that in 2008?
Offer a terse response. 0.99. What is the ratio of the Area (% of total land area) in Ghana in 2006 to that in 2008?
Ensure brevity in your answer.  0.98. What is the ratio of the Area (% of total land area) in Mauritius in 2006 to that in 2008?
Ensure brevity in your answer.  1.03. What is the ratio of the Area (% of total land area) of Tunisia in 2006 to that in 2008?
Keep it short and to the point. 0.99. What is the ratio of the Area (% of total land area) in Least developed countries in 2006 to that in 2009?
Provide a succinct answer. 0.99. What is the ratio of the Area (% of total land area) of Ghana in 2006 to that in 2009?
Give a very brief answer. 0.98. What is the ratio of the Area (% of total land area) in Mauritius in 2006 to that in 2009?
Your answer should be very brief. 1.03. What is the ratio of the Area (% of total land area) in Least developed countries in 2006 to that in 2010?
Provide a succinct answer. 0.98. What is the ratio of the Area (% of total land area) of Ghana in 2006 to that in 2010?
Provide a succinct answer. 0.98. What is the ratio of the Area (% of total land area) of Mauritius in 2006 to that in 2010?
Offer a very short reply. 1.03. What is the ratio of the Area (% of total land area) in Tunisia in 2006 to that in 2010?
Keep it short and to the point. 0.98. What is the ratio of the Area (% of total land area) of Least developed countries in 2006 to that in 2011?
Your response must be concise. 1.01. What is the ratio of the Area (% of total land area) in Ghana in 2006 to that in 2011?
Provide a short and direct response. 0.97. What is the ratio of the Area (% of total land area) of Mauritius in 2006 to that in 2011?
Provide a succinct answer. 1.06. What is the ratio of the Area (% of total land area) of Tunisia in 2006 to that in 2011?
Give a very brief answer. 0.97. What is the ratio of the Area (% of total land area) of Ghana in 2006 to that in 2012?
Your response must be concise. 0.97. What is the ratio of the Area (% of total land area) in Mauritius in 2006 to that in 2012?
Your response must be concise. 1.08. What is the ratio of the Area (% of total land area) in Tunisia in 2006 to that in 2012?
Offer a very short reply. 0.99. What is the ratio of the Area (% of total land area) of Least developed countries in 2006 to that in 2013?
Your response must be concise. 1.01. What is the ratio of the Area (% of total land area) in Ghana in 2006 to that in 2013?
Make the answer very short. 0.97. What is the ratio of the Area (% of total land area) of Mauritius in 2006 to that in 2013?
Provide a short and direct response. 1.09. What is the ratio of the Area (% of total land area) in Tunisia in 2006 to that in 2013?
Your response must be concise. 0.99. What is the ratio of the Area (% of total land area) of Ghana in 2007 to that in 2008?
Your response must be concise. 0.99. What is the ratio of the Area (% of total land area) in Tunisia in 2007 to that in 2008?
Keep it short and to the point. 0.99. What is the ratio of the Area (% of total land area) of Ghana in 2007 to that in 2009?
Your answer should be very brief. 0.99. What is the ratio of the Area (% of total land area) of Least developed countries in 2007 to that in 2010?
Provide a succinct answer. 0.99. What is the ratio of the Area (% of total land area) in Ghana in 2007 to that in 2010?
Offer a very short reply. 0.99. What is the ratio of the Area (% of total land area) in Mauritius in 2007 to that in 2010?
Your answer should be compact. 1.01. What is the ratio of the Area (% of total land area) of Tunisia in 2007 to that in 2010?
Make the answer very short. 0.98. What is the ratio of the Area (% of total land area) in Least developed countries in 2007 to that in 2011?
Ensure brevity in your answer.  1.02. What is the ratio of the Area (% of total land area) of Ghana in 2007 to that in 2011?
Offer a very short reply. 0.98. What is the ratio of the Area (% of total land area) of Mauritius in 2007 to that in 2011?
Offer a very short reply. 1.03. What is the ratio of the Area (% of total land area) of Tunisia in 2007 to that in 2011?
Provide a succinct answer. 0.97. What is the ratio of the Area (% of total land area) in Least developed countries in 2007 to that in 2012?
Your response must be concise. 1.01. What is the ratio of the Area (% of total land area) in Ghana in 2007 to that in 2012?
Ensure brevity in your answer.  0.98. What is the ratio of the Area (% of total land area) in Mauritius in 2007 to that in 2012?
Offer a very short reply. 1.06. What is the ratio of the Area (% of total land area) of Least developed countries in 2007 to that in 2013?
Your answer should be compact. 1.01. What is the ratio of the Area (% of total land area) in Ghana in 2007 to that in 2013?
Your response must be concise. 0.98. What is the ratio of the Area (% of total land area) in Mauritius in 2007 to that in 2013?
Your answer should be very brief. 1.07. What is the ratio of the Area (% of total land area) of Tunisia in 2007 to that in 2013?
Ensure brevity in your answer.  0.99. What is the ratio of the Area (% of total land area) of Least developed countries in 2008 to that in 2009?
Give a very brief answer. 1. What is the ratio of the Area (% of total land area) of Ghana in 2008 to that in 2009?
Your answer should be compact. 1. What is the ratio of the Area (% of total land area) in Tunisia in 2008 to that in 2009?
Ensure brevity in your answer.  1.01. What is the ratio of the Area (% of total land area) in Ghana in 2008 to that in 2010?
Offer a very short reply. 1. What is the ratio of the Area (% of total land area) of Mauritius in 2008 to that in 2010?
Provide a succinct answer. 1. What is the ratio of the Area (% of total land area) of Tunisia in 2008 to that in 2010?
Offer a terse response. 0.98. What is the ratio of the Area (% of total land area) of Least developed countries in 2008 to that in 2011?
Your answer should be compact. 1.02. What is the ratio of the Area (% of total land area) in Mauritius in 2008 to that in 2011?
Provide a succinct answer. 1.02. What is the ratio of the Area (% of total land area) of Least developed countries in 2008 to that in 2012?
Your answer should be compact. 1.01. What is the ratio of the Area (% of total land area) in Mauritius in 2008 to that in 2012?
Offer a terse response. 1.05. What is the ratio of the Area (% of total land area) in Least developed countries in 2008 to that in 2013?
Give a very brief answer. 1.02. What is the ratio of the Area (% of total land area) in Mauritius in 2008 to that in 2013?
Keep it short and to the point. 1.06. What is the ratio of the Area (% of total land area) in Tunisia in 2008 to that in 2013?
Your answer should be very brief. 0.99. What is the ratio of the Area (% of total land area) in Ghana in 2009 to that in 2010?
Provide a short and direct response. 1. What is the ratio of the Area (% of total land area) of Tunisia in 2009 to that in 2010?
Provide a short and direct response. 0.98. What is the ratio of the Area (% of total land area) in Least developed countries in 2009 to that in 2011?
Provide a short and direct response. 1.03. What is the ratio of the Area (% of total land area) of Ghana in 2009 to that in 2011?
Your response must be concise. 0.99. What is the ratio of the Area (% of total land area) of Mauritius in 2009 to that in 2011?
Provide a short and direct response. 1.02. What is the ratio of the Area (% of total land area) of Tunisia in 2009 to that in 2011?
Your response must be concise. 0.97. What is the ratio of the Area (% of total land area) in Least developed countries in 2009 to that in 2012?
Your answer should be very brief. 1.02. What is the ratio of the Area (% of total land area) of Ghana in 2009 to that in 2012?
Your response must be concise. 0.99. What is the ratio of the Area (% of total land area) in Mauritius in 2009 to that in 2012?
Ensure brevity in your answer.  1.05. What is the ratio of the Area (% of total land area) of Tunisia in 2009 to that in 2012?
Offer a very short reply. 0.99. What is the ratio of the Area (% of total land area) in Least developed countries in 2009 to that in 2013?
Your answer should be very brief. 1.02. What is the ratio of the Area (% of total land area) in Mauritius in 2009 to that in 2013?
Your answer should be very brief. 1.06. What is the ratio of the Area (% of total land area) of Tunisia in 2009 to that in 2013?
Provide a succinct answer. 0.98. What is the ratio of the Area (% of total land area) in Least developed countries in 2010 to that in 2011?
Keep it short and to the point. 1.03. What is the ratio of the Area (% of total land area) in Mauritius in 2010 to that in 2011?
Provide a short and direct response. 1.02. What is the ratio of the Area (% of total land area) in Tunisia in 2010 to that in 2011?
Provide a short and direct response. 1. What is the ratio of the Area (% of total land area) of Least developed countries in 2010 to that in 2012?
Provide a short and direct response. 1.02. What is the ratio of the Area (% of total land area) in Mauritius in 2010 to that in 2012?
Keep it short and to the point. 1.05. What is the ratio of the Area (% of total land area) in Tunisia in 2010 to that in 2012?
Provide a succinct answer. 1.01. What is the ratio of the Area (% of total land area) in Least developed countries in 2010 to that in 2013?
Provide a succinct answer. 1.03. What is the ratio of the Area (% of total land area) of Ghana in 2010 to that in 2013?
Ensure brevity in your answer.  0.99. What is the ratio of the Area (% of total land area) in Mauritius in 2010 to that in 2013?
Provide a short and direct response. 1.06. What is the ratio of the Area (% of total land area) of Tunisia in 2010 to that in 2013?
Give a very brief answer. 1.01. What is the ratio of the Area (% of total land area) of Least developed countries in 2011 to that in 2012?
Offer a terse response. 0.99. What is the ratio of the Area (% of total land area) of Ghana in 2011 to that in 2012?
Offer a terse response. 1. What is the ratio of the Area (% of total land area) in Mauritius in 2011 to that in 2012?
Make the answer very short. 1.02. What is the ratio of the Area (% of total land area) of Tunisia in 2011 to that in 2012?
Your answer should be compact. 1.02. What is the ratio of the Area (% of total land area) of Ghana in 2011 to that in 2013?
Your response must be concise. 1. What is the ratio of the Area (% of total land area) in Mauritius in 2011 to that in 2013?
Keep it short and to the point. 1.03. What is the ratio of the Area (% of total land area) in Tunisia in 2011 to that in 2013?
Offer a very short reply. 1.01. What is the ratio of the Area (% of total land area) in Mauritius in 2012 to that in 2013?
Provide a short and direct response. 1.01. What is the ratio of the Area (% of total land area) of Tunisia in 2012 to that in 2013?
Make the answer very short. 1. What is the difference between the highest and the second highest Area (% of total land area) in Least developed countries?
Your response must be concise. 0.14. What is the difference between the highest and the second highest Area (% of total land area) of Ghana?
Offer a terse response. 0.09. What is the difference between the highest and the second highest Area (% of total land area) in Mauritius?
Give a very brief answer. 0.99. What is the difference between the highest and the second highest Area (% of total land area) in Tunisia?
Make the answer very short. 0.22. What is the difference between the highest and the lowest Area (% of total land area) of Least developed countries?
Provide a short and direct response. 1.21. What is the difference between the highest and the lowest Area (% of total land area) of Ghana?
Ensure brevity in your answer.  1.85. What is the difference between the highest and the lowest Area (% of total land area) in Mauritius?
Make the answer very short. 3.94. What is the difference between the highest and the lowest Area (% of total land area) in Tunisia?
Offer a very short reply. 1.82. 